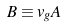<formula> <loc_0><loc_0><loc_500><loc_500>B \equiv v _ { g } A</formula> 